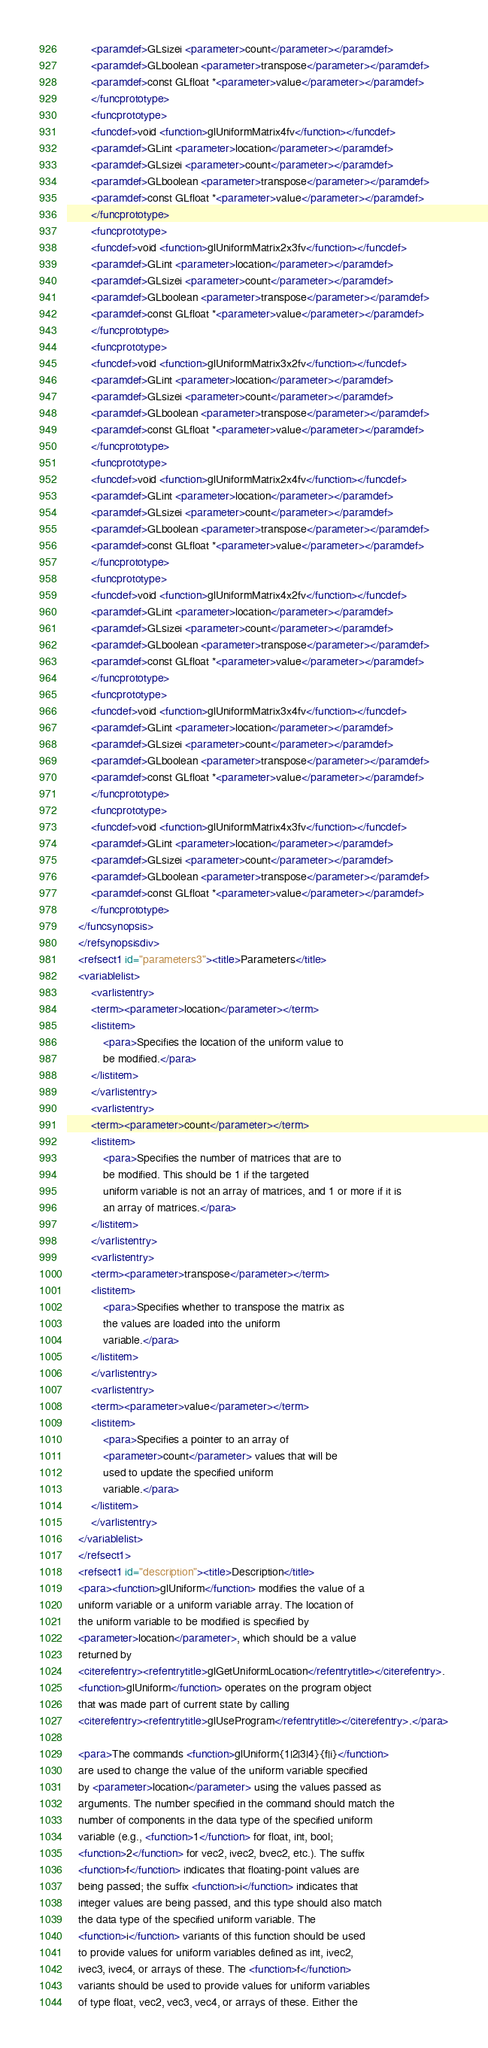Convert code to text. <code><loc_0><loc_0><loc_500><loc_500><_XML_>		<paramdef>GLsizei <parameter>count</parameter></paramdef>
		<paramdef>GLboolean <parameter>transpose</parameter></paramdef>
		<paramdef>const GLfloat *<parameter>value</parameter></paramdef>
	    </funcprototype>
	    <funcprototype>
		<funcdef>void <function>glUniformMatrix4fv</function></funcdef>
		<paramdef>GLint <parameter>location</parameter></paramdef>
		<paramdef>GLsizei <parameter>count</parameter></paramdef>
		<paramdef>GLboolean <parameter>transpose</parameter></paramdef>
		<paramdef>const GLfloat *<parameter>value</parameter></paramdef>
	    </funcprototype>
	    <funcprototype>
		<funcdef>void <function>glUniformMatrix2x3fv</function></funcdef>
		<paramdef>GLint <parameter>location</parameter></paramdef>
		<paramdef>GLsizei <parameter>count</parameter></paramdef>
		<paramdef>GLboolean <parameter>transpose</parameter></paramdef>
		<paramdef>const GLfloat *<parameter>value</parameter></paramdef>
	    </funcprototype>
	    <funcprototype>
		<funcdef>void <function>glUniformMatrix3x2fv</function></funcdef>
		<paramdef>GLint <parameter>location</parameter></paramdef>
		<paramdef>GLsizei <parameter>count</parameter></paramdef>
		<paramdef>GLboolean <parameter>transpose</parameter></paramdef>
		<paramdef>const GLfloat *<parameter>value</parameter></paramdef>
	    </funcprototype>
	    <funcprototype>
		<funcdef>void <function>glUniformMatrix2x4fv</function></funcdef>
		<paramdef>GLint <parameter>location</parameter></paramdef>
		<paramdef>GLsizei <parameter>count</parameter></paramdef>
		<paramdef>GLboolean <parameter>transpose</parameter></paramdef>
		<paramdef>const GLfloat *<parameter>value</parameter></paramdef>
	    </funcprototype>
	    <funcprototype>
		<funcdef>void <function>glUniformMatrix4x2fv</function></funcdef>
		<paramdef>GLint <parameter>location</parameter></paramdef>
		<paramdef>GLsizei <parameter>count</parameter></paramdef>
		<paramdef>GLboolean <parameter>transpose</parameter></paramdef>
		<paramdef>const GLfloat *<parameter>value</parameter></paramdef>
	    </funcprototype>
	    <funcprototype>
		<funcdef>void <function>glUniformMatrix3x4fv</function></funcdef>
		<paramdef>GLint <parameter>location</parameter></paramdef>
		<paramdef>GLsizei <parameter>count</parameter></paramdef>
		<paramdef>GLboolean <parameter>transpose</parameter></paramdef>
		<paramdef>const GLfloat *<parameter>value</parameter></paramdef>
	    </funcprototype>
	    <funcprototype>
		<funcdef>void <function>glUniformMatrix4x3fv</function></funcdef>
		<paramdef>GLint <parameter>location</parameter></paramdef>
		<paramdef>GLsizei <parameter>count</parameter></paramdef>
		<paramdef>GLboolean <parameter>transpose</parameter></paramdef>
		<paramdef>const GLfloat *<parameter>value</parameter></paramdef>
	    </funcprototype>
	</funcsynopsis>
    </refsynopsisdiv>
    <refsect1 id="parameters3"><title>Parameters</title>
	<variablelist>
	    <varlistentry>
		<term><parameter>location</parameter></term>
		<listitem>
		    <para>Specifies the location of the uniform value to
		    be modified.</para>
		</listitem>
	    </varlistentry>
	    <varlistentry>
		<term><parameter>count</parameter></term>
		<listitem>
		    <para>Specifies the number of matrices that are to
		    be modified. This should be 1 if the targeted
		    uniform variable is not an array of matrices, and 1 or more if it is
		    an array of matrices.</para>
		</listitem>
	    </varlistentry>
	    <varlistentry>
		<term><parameter>transpose</parameter></term>
		<listitem>
		    <para>Specifies whether to transpose the matrix as
		    the values are loaded into the uniform
		    variable.</para>
		</listitem>
	    </varlistentry>
	    <varlistentry>
		<term><parameter>value</parameter></term>
		<listitem>
		    <para>Specifies a pointer to an array of
		    <parameter>count</parameter> values that will be
		    used to update the specified uniform
		    variable.</para>
		</listitem>
	    </varlistentry>
	</variablelist>
    </refsect1>
    <refsect1 id="description"><title>Description</title>
	<para><function>glUniform</function> modifies the value of a
	uniform variable or a uniform variable array. The location of
	the uniform variable to be modified is specified by
	<parameter>location</parameter>, which should be a value
	returned by
	<citerefentry><refentrytitle>glGetUniformLocation</refentrytitle></citerefentry>.
	<function>glUniform</function> operates on the program object
	that was made part of current state by calling
	<citerefentry><refentrytitle>glUseProgram</refentrytitle></citerefentry>.</para>

	<para>The commands <function>glUniform{1|2|3|4}{f|i}</function>
	are used to change the value of the uniform variable specified
	by <parameter>location</parameter> using the values passed as
	arguments. The number specified in the command should match the
	number of components in the data type of the specified uniform
	variable (e.g., <function>1</function> for float, int, bool;
	<function>2</function> for vec2, ivec2, bvec2, etc.). The suffix
	<function>f</function> indicates that floating-point values are
	being passed; the suffix <function>i</function> indicates that
	integer values are being passed, and this type should also match
	the data type of the specified uniform variable. The
	<function>i</function> variants of this function should be used
	to provide values for uniform variables defined as int, ivec2,
	ivec3, ivec4, or arrays of these. The <function>f</function>
	variants should be used to provide values for uniform variables
	of type float, vec2, vec3, vec4, or arrays of these. Either the</code> 